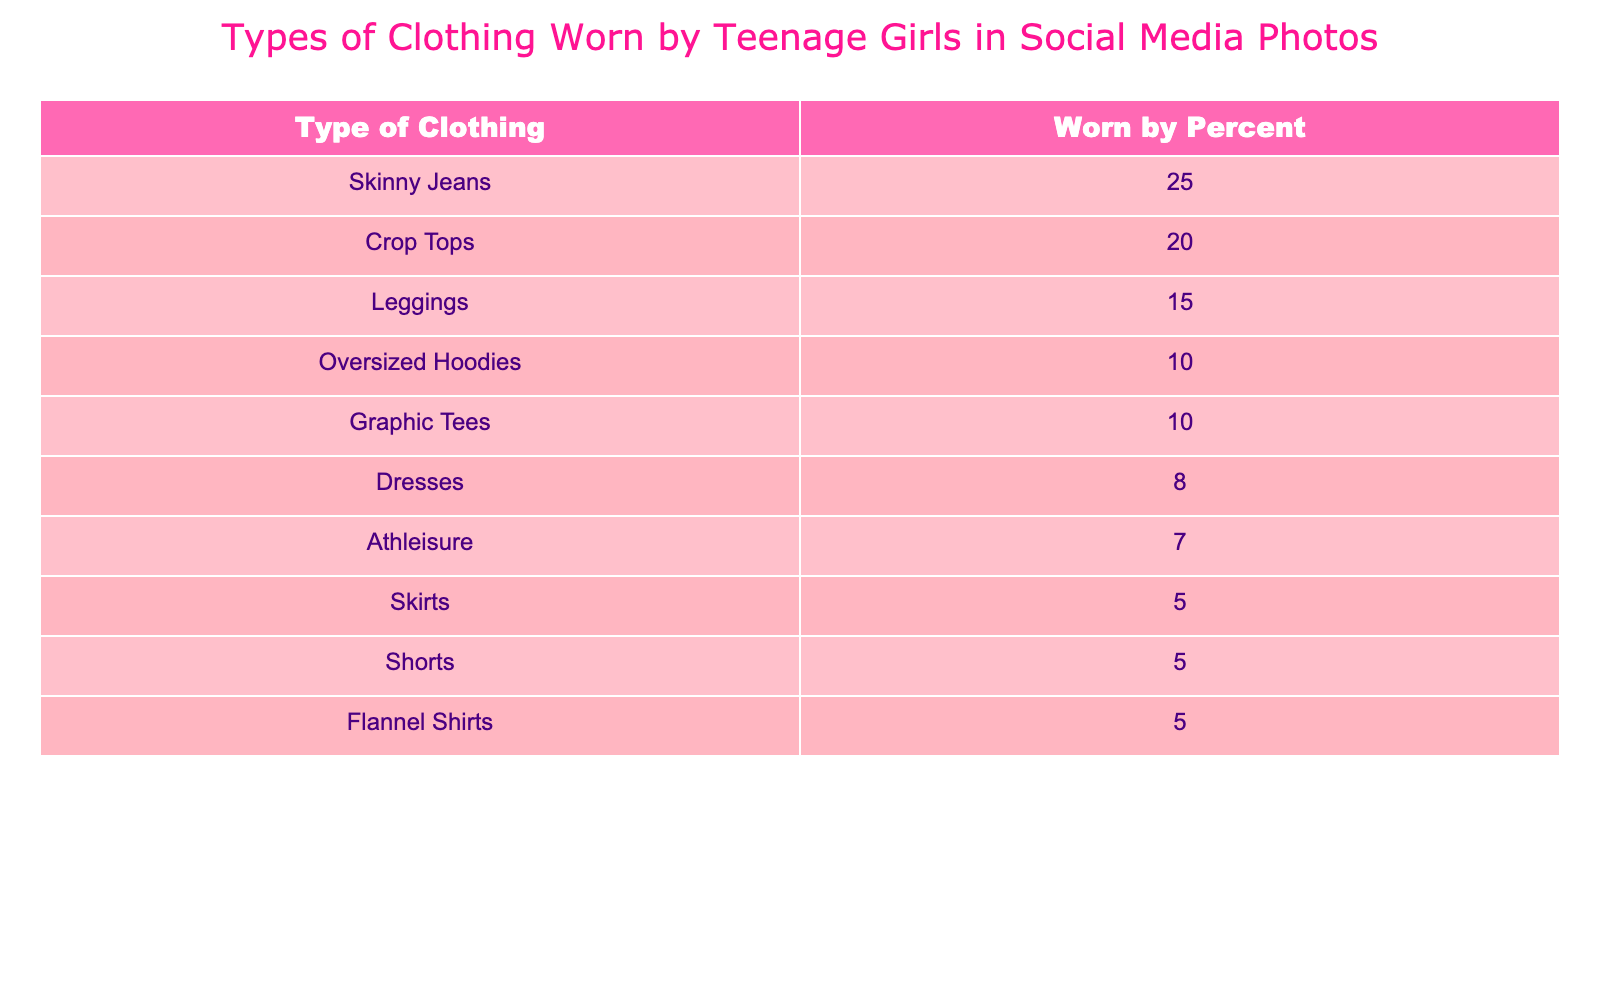What type of clothing is worn by the highest percentage of teenage girls? According to the table, "Skinny Jeans" are worn by 25% of teenage girls, which is the highest percentage compared to other clothing types.
Answer: Skinny Jeans What percentage of teenage girls wear leggings? The table shows that "Leggings" are worn by 15% of teenage girls, which can be directly referenced from the data.
Answer: 15% How many types of clothing are listed in the table? By counting the rows in the table, there are a total of 10 types of clothing listed.
Answer: 10 What is the combined percentage of teenage girls wearing Crop Tops and Dresses? The percentage of girls wearing Crop Tops is 20% and for Dresses it is 8%. Adding these together, 20 + 8 results in 28%.
Answer: 28% Is it true that more than half of the teenage girls wear either Skirts or Shorts? The table lists "Skirts" at 5% and "Shorts" at 5%. Combined, they total 10%, which is not more than half. Therefore, the statement is false.
Answer: No What percentage of teenage girls wear either Oversized Hoodies or Athleisure? The percentage for Oversized Hoodies is 10% and for Athleisure, it's 7%. Adding these two percentages gives 10 + 7 = 17%.
Answer: 17% Which type of clothing accounts for the least percentage among teenage girls? By looking through the table, both "Skirts" and "Shorts" are listed at 5%, which is the smallest percentage shown in the data.
Answer: Skirts and Shorts What is the difference between the percentage of girls wearing Crop Tops and those wearing Athleisure? From the table, Crop Tops are worn by 20%, while Athleisure is worn by 7%. The difference is calculated as 20 - 7 = 13%.
Answer: 13% What is the average percentage of clothing types listed in the table? To find the average, add all the percentages: 25 + 20 + 15 + 10 + 10 + 8 + 7 + 5 + 5 + 5 = 105. There are 10 clothing types, so 105/10 = 10.5%.
Answer: 10.5% 